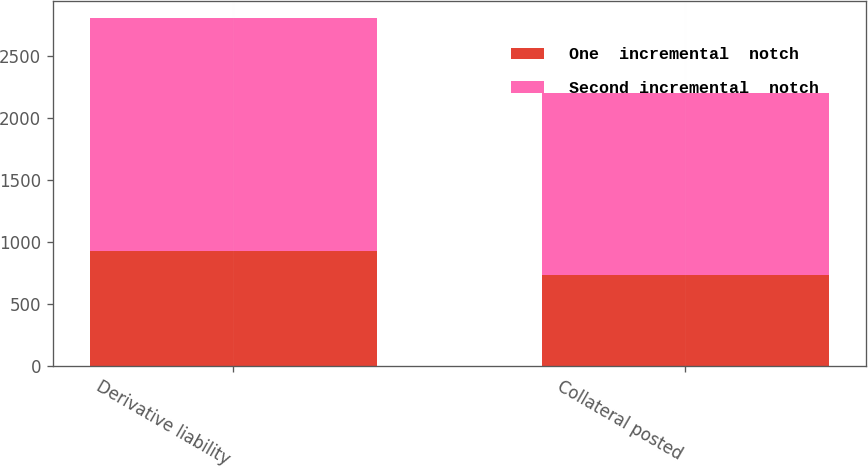Convert chart to OTSL. <chart><loc_0><loc_0><loc_500><loc_500><stacked_bar_chart><ecel><fcel>Derivative liability<fcel>Collateral posted<nl><fcel>One  incremental  notch<fcel>927<fcel>733<nl><fcel>Second incremental  notch<fcel>1878<fcel>1467<nl></chart> 